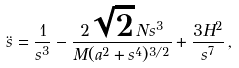<formula> <loc_0><loc_0><loc_500><loc_500>\ddot { s } = \frac { 1 } { s ^ { 3 } } - \frac { 2 \sqrt { 2 } \, N s ^ { 3 } } { M ( a ^ { 2 } + s ^ { 4 } ) ^ { 3 / 2 } } + \frac { 3 H ^ { 2 } } { s ^ { 7 } } \, ,</formula> 